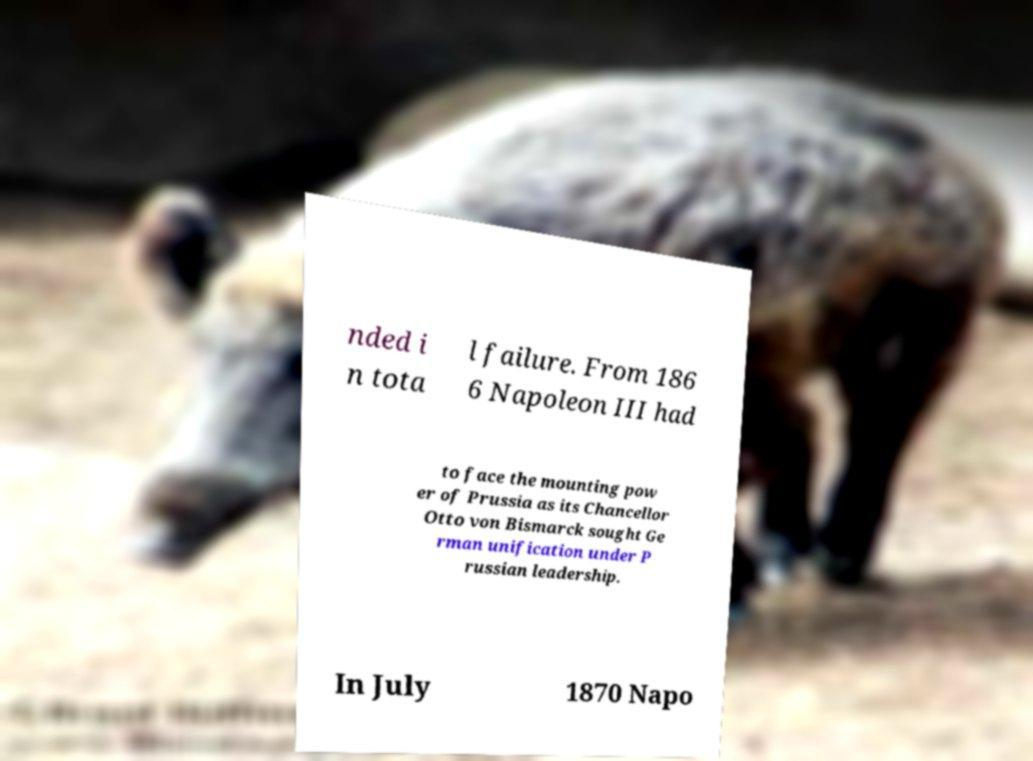Can you accurately transcribe the text from the provided image for me? nded i n tota l failure. From 186 6 Napoleon III had to face the mounting pow er of Prussia as its Chancellor Otto von Bismarck sought Ge rman unification under P russian leadership. In July 1870 Napo 